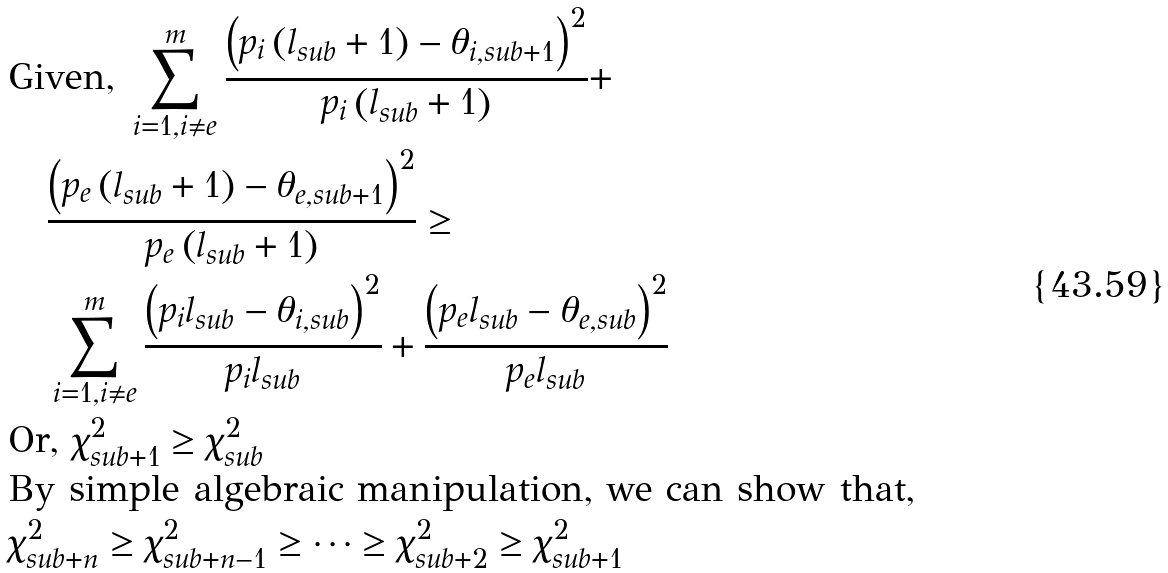Convert formula to latex. <formula><loc_0><loc_0><loc_500><loc_500>& \text {Given, } \sum ^ { m } _ { i = 1 , i \neq e } \frac { \left ( p _ { i } \left ( l _ { s u b } + 1 \right ) - \theta _ { i , s u b + 1 } \right ) ^ { 2 } } { p _ { i } \left ( l _ { s u b } + 1 \right ) } + \\ & \quad \frac { \left ( p _ { e } \left ( l _ { s u b } + 1 \right ) - \theta _ { e , s u b + 1 } \right ) ^ { 2 } } { p _ { e } \left ( l _ { s u b } + 1 \right ) } \geq \\ & \quad \sum ^ { m } _ { i = 1 , i \neq e } \frac { \left ( p _ { i } l _ { s u b } - \theta _ { i , s u b } \right ) ^ { 2 } } { p _ { i } l _ { s u b } } + \frac { \left ( p _ { e } l _ { s u b } - \theta _ { e , s u b } \right ) ^ { 2 } } { p _ { e } l _ { s u b } } \\ & \text {Or, } \chi ^ { 2 } _ { s u b + 1 } \geq \chi ^ { 2 } _ { s u b } \\ & \text {By simple algebraic manipulation, we can show that, } \\ & \chi ^ { 2 } _ { s u b + n } \geq \chi ^ { 2 } _ { s u b + n - 1 } \geq \dots \geq \chi ^ { 2 } _ { s u b + 2 } \geq \chi ^ { 2 } _ { s u b + 1 }</formula> 